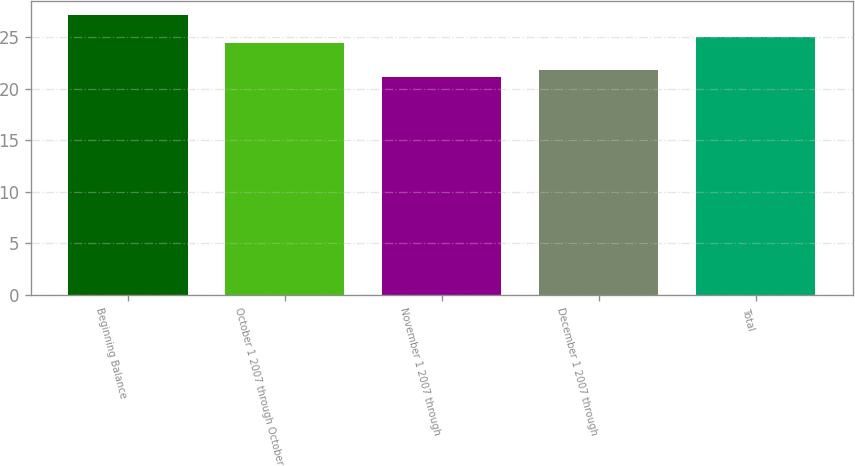Convert chart to OTSL. <chart><loc_0><loc_0><loc_500><loc_500><bar_chart><fcel>Beginning Balance<fcel>October 1 2007 through October<fcel>November 1 2007 through<fcel>December 1 2007 through<fcel>Total<nl><fcel>27.18<fcel>24.42<fcel>21.17<fcel>21.77<fcel>25.02<nl></chart> 